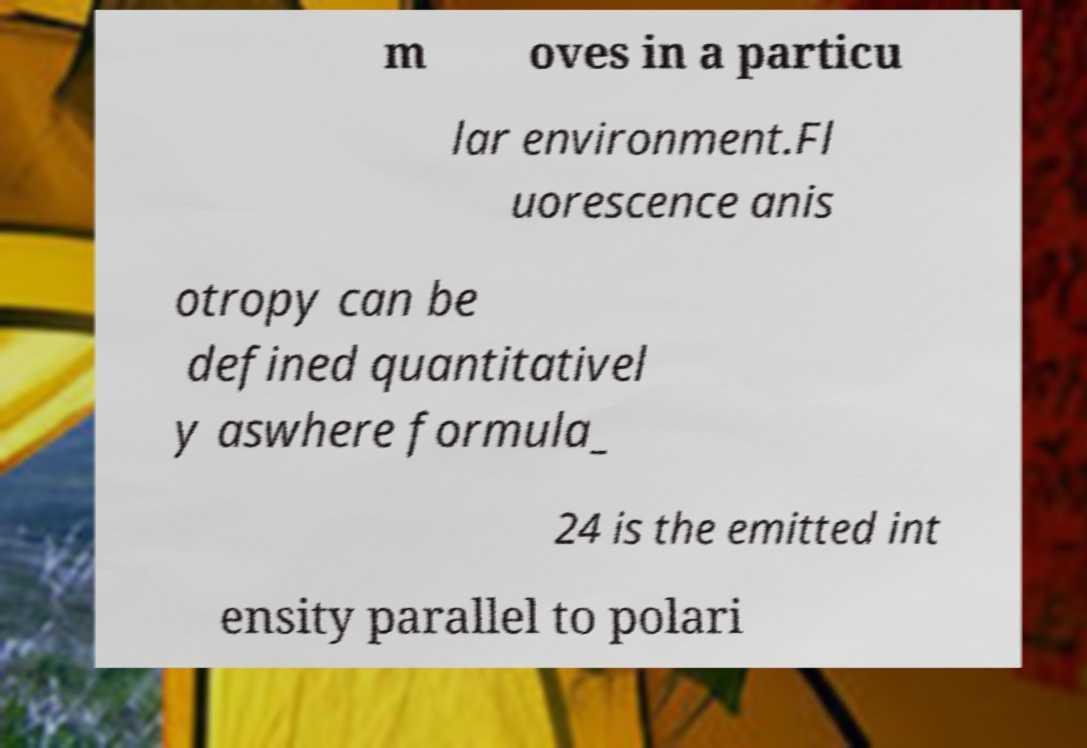What messages or text are displayed in this image? I need them in a readable, typed format. m oves in a particu lar environment.Fl uorescence anis otropy can be defined quantitativel y aswhere formula_ 24 is the emitted int ensity parallel to polari 